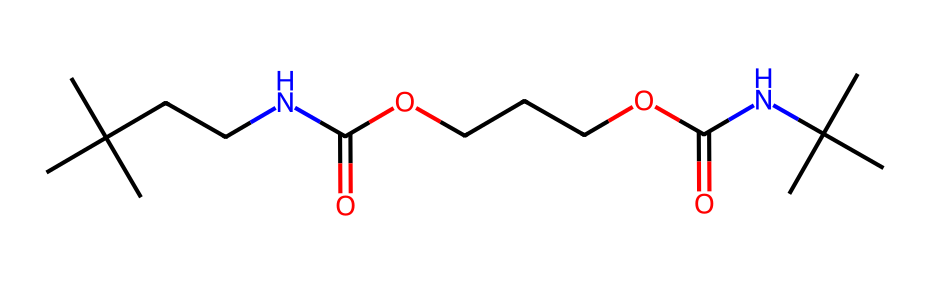What is the functional group present in this chemical? The SMILES representation indicates the presence of a carboxylic acid group (C(=O)O), as seen in the formula. This is identified by the carbon atom double-bonded to oxygen and single-bonded to hydroxyl (-OH).
Answer: carboxylic acid How many nitrogen atoms are in the chemical structure? In the SMILES representation, "N" typically represents nitrogen. Counting the occurrences of "N" in the structure reveals that there are two nitrogen atoms present.
Answer: 2 What type of linkage is formed between the components of this polymer? The presence of the amide functional groups (–C(=O)N–) indicates that the polymer is formed via amide linkages, which are characteristic of polyurethanes. These linkages are formed when the carboxylic acid reacts with amines.
Answer: amide linkages How many carbon atoms does this chemical contain? By analyzing the SMILES structure, each "C" represents a carbon atom, and by counting them, we find a total of 12 carbon atoms.
Answer: 12 What is the primary application of this chemical in handball court flooring? Polyurethane foams are prized for their elasticity and shock-absorbing properties, making them suitable for flooring that provides good grip and cushioning for sports like handball.
Answer: flooring 